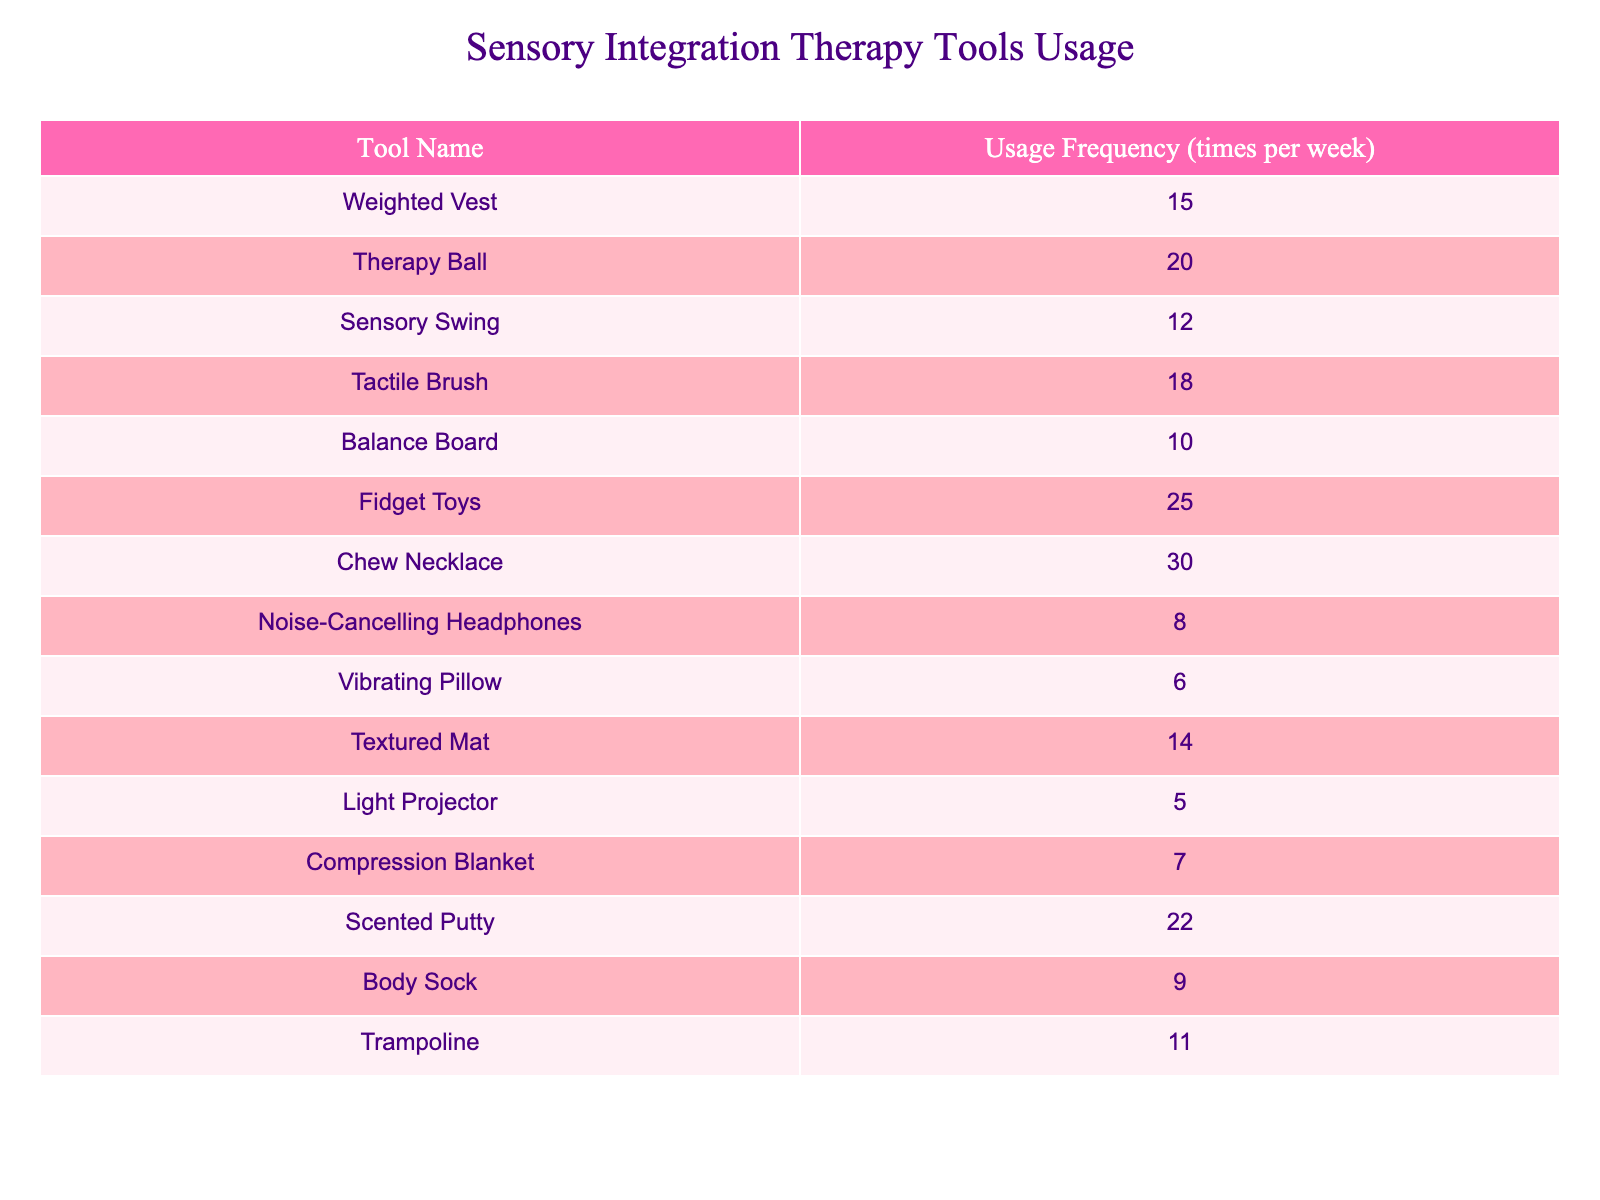What is the most frequently used sensory integration therapy tool? The table lists the usage frequency of various tools. Fidget Toys have the highest usage frequency at 25 times per week.
Answer: Fidget Toys How many times per week is the Chew Necklace used? The table indicates the frequency of the Chew Necklace's usage, which is listed as 30 times per week.
Answer: 30 Which tool is used the least frequently according to the table? By examining the usage frequencies, the tool with the lowest frequency is the Light Projector, which is used 5 times per week.
Answer: Light Projector What is the average usage frequency of all tools listed? To find the average, sum all the usage frequencies (15 + 20 + 12 + 18 + 10 + 25 + 30 + 8 + 6 + 14 + 5 + 7 + 22 + 9 + 11 =  60) and divide by the number of tools (15). The average is 15.
Answer: 15 Is the Tactile Brush used more frequently than the noise-cancelling headphones? Comparing the frequencies, the Tactile Brush is used 18 times per week, while the Noise-Cancelling Headphones are used 8 times per week, making the Tactile Brush used more frequently.
Answer: Yes What is the total usage for the Tactile Brush, Scented Putty, and Therapy Ball combined? Sum the frequencies of these three tools: Tactile Brush (18) + Scented Putty (22) + Therapy Ball (20) = 60.
Answer: 60 How many tools have a usage frequency of 10 or fewer times per week? From the table, the tools used 10 or fewer times are Noise-Cancelling Headphones (8), Vibrating Pillow (6), and Compression Blanket (7). That totals three tools.
Answer: 3 Which tool has a higher usage frequency: the Balance Board or the Trampoline? The Balance Board is used 10 times per week, while the Trampoline is used 11 times a week. Hence, the Trampoline has a higher usage frequency.
Answer: Trampoline How much more frequently is the Chew Necklace used compared to the Vibrating Pillow? The Chew Necklace is used 30 times per week, while the Vibrating Pillow is used 6 times per week. The difference is 30 - 6 = 24.
Answer: 24 If we exclude the tool used most frequently, what is the new average usage frequency of the remaining tools? Excluding the Fidget Toys (25), sum the frequencies of the remaining 14 tools (15 + 20 + 12 + 18 + 10 + 30 + 8 + 6 + 14 + 5 + 7 + 22 + 9 + 11 =  29). The new average becomes 29/14 = 14.5.
Answer: 14.5 